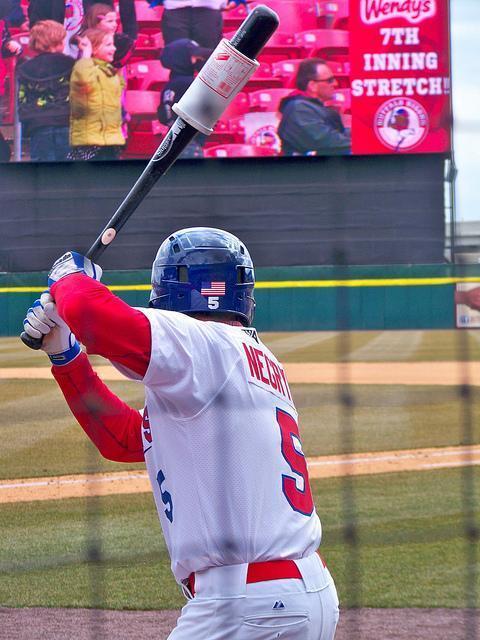How many people are visible?
Give a very brief answer. 1. 